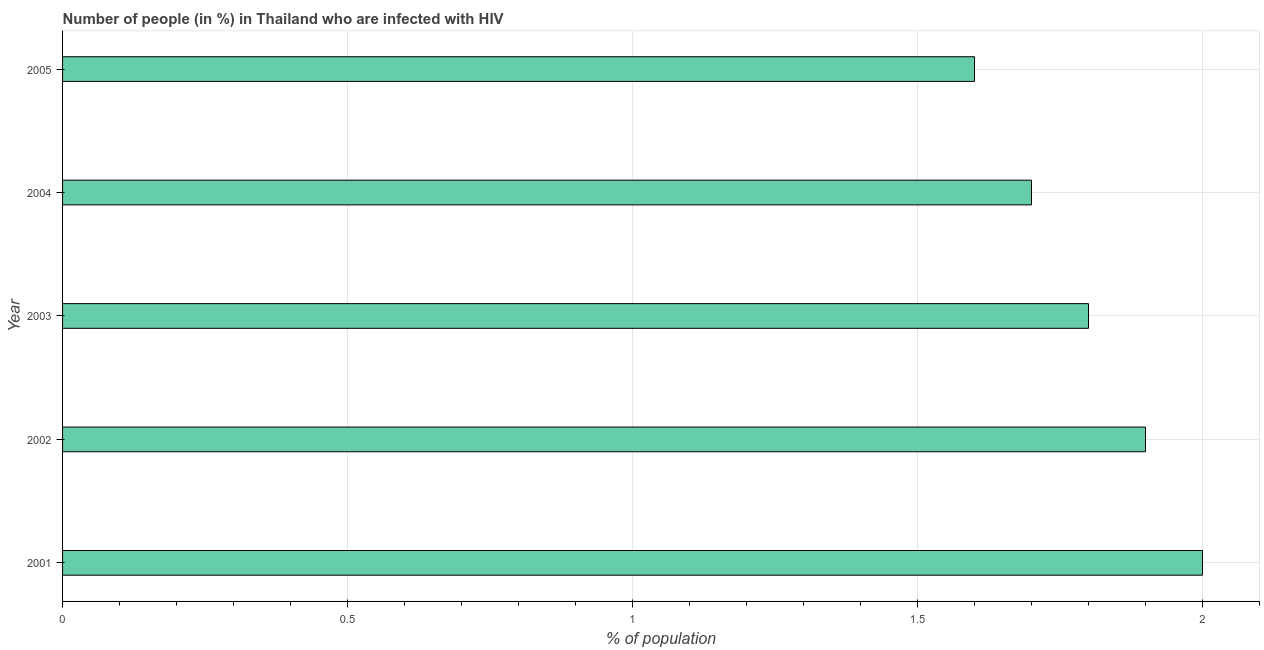What is the title of the graph?
Offer a terse response. Number of people (in %) in Thailand who are infected with HIV. What is the label or title of the X-axis?
Give a very brief answer. % of population. What is the label or title of the Y-axis?
Your response must be concise. Year. Across all years, what is the maximum number of people infected with hiv?
Provide a short and direct response. 2. In which year was the number of people infected with hiv minimum?
Provide a succinct answer. 2005. What is the sum of the number of people infected with hiv?
Offer a terse response. 9. What is the difference between the number of people infected with hiv in 2003 and 2005?
Keep it short and to the point. 0.2. What is the average number of people infected with hiv per year?
Give a very brief answer. 1.8. Do a majority of the years between 2002 and 2003 (inclusive) have number of people infected with hiv greater than 1 %?
Ensure brevity in your answer.  Yes. What is the difference between the highest and the second highest number of people infected with hiv?
Provide a succinct answer. 0.1. What is the difference between the highest and the lowest number of people infected with hiv?
Your answer should be compact. 0.4. In how many years, is the number of people infected with hiv greater than the average number of people infected with hiv taken over all years?
Give a very brief answer. 2. How many bars are there?
Provide a short and direct response. 5. What is the % of population in 2001?
Your answer should be compact. 2. What is the % of population of 2002?
Offer a very short reply. 1.9. What is the % of population of 2003?
Provide a succinct answer. 1.8. What is the difference between the % of population in 2001 and 2002?
Keep it short and to the point. 0.1. What is the difference between the % of population in 2001 and 2003?
Your response must be concise. 0.2. What is the difference between the % of population in 2001 and 2004?
Give a very brief answer. 0.3. What is the difference between the % of population in 2001 and 2005?
Offer a terse response. 0.4. What is the difference between the % of population in 2002 and 2004?
Give a very brief answer. 0.2. What is the difference between the % of population in 2002 and 2005?
Offer a terse response. 0.3. What is the difference between the % of population in 2003 and 2005?
Give a very brief answer. 0.2. What is the ratio of the % of population in 2001 to that in 2002?
Keep it short and to the point. 1.05. What is the ratio of the % of population in 2001 to that in 2003?
Your response must be concise. 1.11. What is the ratio of the % of population in 2001 to that in 2004?
Your answer should be compact. 1.18. What is the ratio of the % of population in 2002 to that in 2003?
Your response must be concise. 1.06. What is the ratio of the % of population in 2002 to that in 2004?
Offer a very short reply. 1.12. What is the ratio of the % of population in 2002 to that in 2005?
Your response must be concise. 1.19. What is the ratio of the % of population in 2003 to that in 2004?
Keep it short and to the point. 1.06. What is the ratio of the % of population in 2004 to that in 2005?
Offer a very short reply. 1.06. 